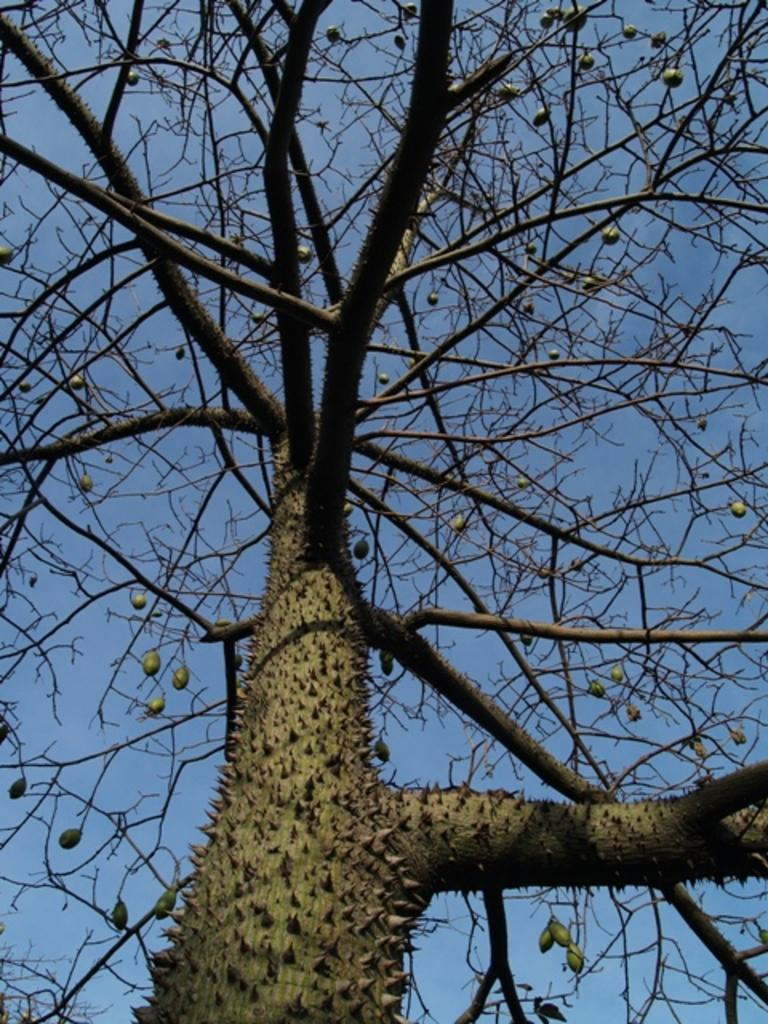What type of plant can be seen in the image? There is a tree with fruits in the image. What can be seen in the background of the image? The sky is visible in the background of the image. How many rabbits can be seen hopping around the tree in the image? There are no rabbits present in the image; it only features a tree with fruits. What scent is emitted by the tree in the image? The image does not provide information about the scent of the tree, so it cannot be determined from the image. 